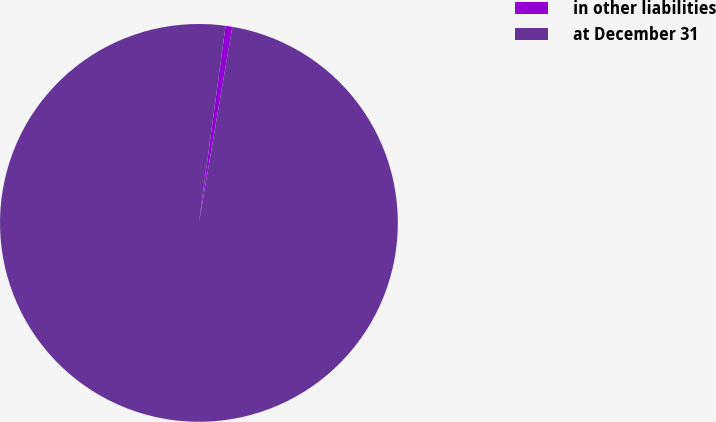<chart> <loc_0><loc_0><loc_500><loc_500><pie_chart><fcel>in other liabilities<fcel>at December 31<nl><fcel>0.55%<fcel>99.45%<nl></chart> 